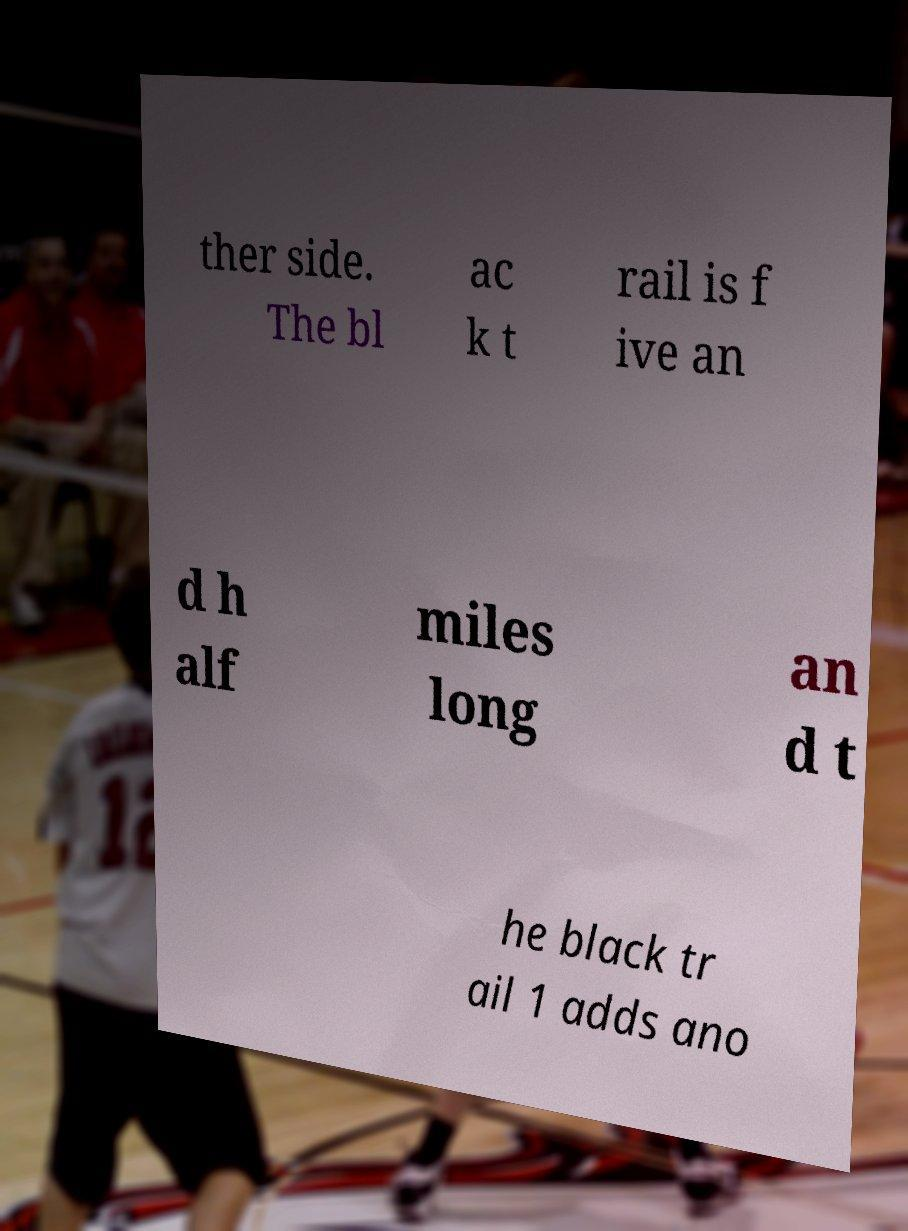There's text embedded in this image that I need extracted. Can you transcribe it verbatim? ther side. The bl ac k t rail is f ive an d h alf miles long an d t he black tr ail 1 adds ano 